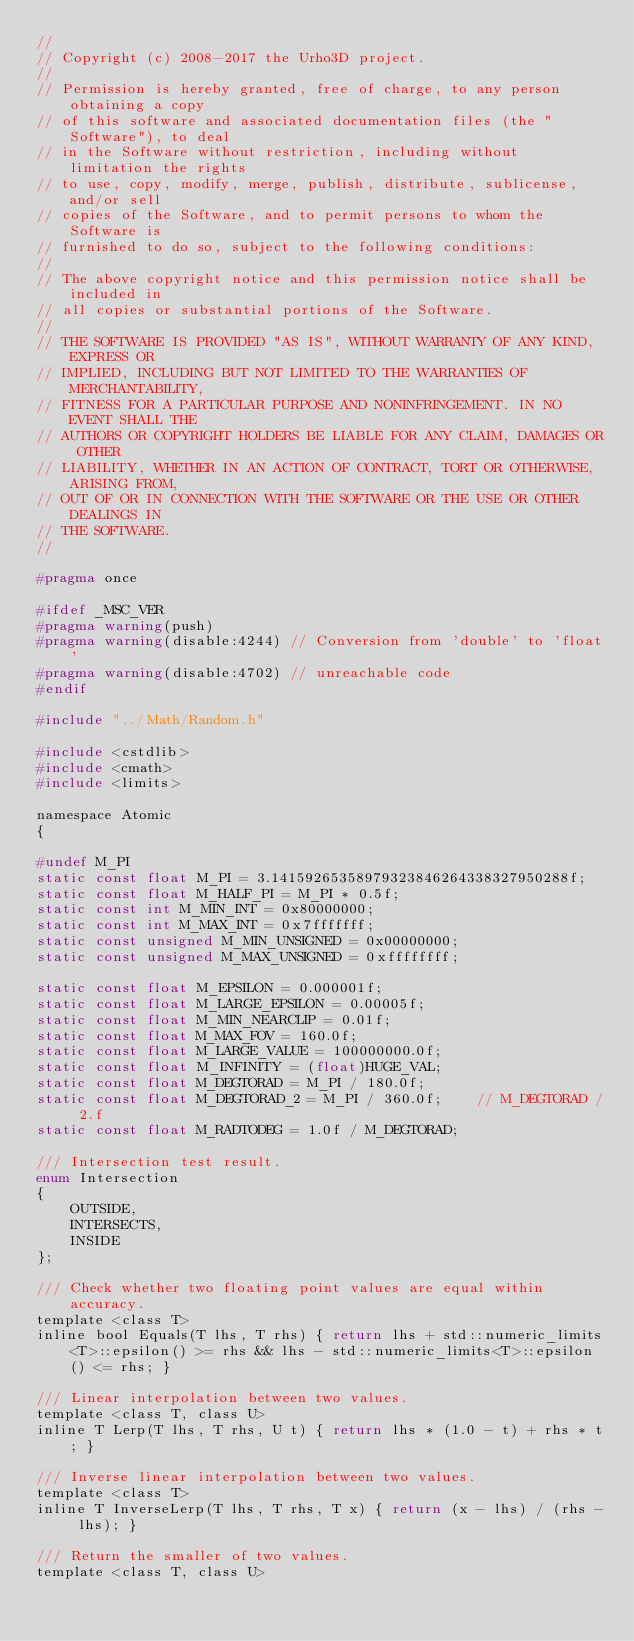Convert code to text. <code><loc_0><loc_0><loc_500><loc_500><_C_>//
// Copyright (c) 2008-2017 the Urho3D project.
//
// Permission is hereby granted, free of charge, to any person obtaining a copy
// of this software and associated documentation files (the "Software"), to deal
// in the Software without restriction, including without limitation the rights
// to use, copy, modify, merge, publish, distribute, sublicense, and/or sell
// copies of the Software, and to permit persons to whom the Software is
// furnished to do so, subject to the following conditions:
//
// The above copyright notice and this permission notice shall be included in
// all copies or substantial portions of the Software.
//
// THE SOFTWARE IS PROVIDED "AS IS", WITHOUT WARRANTY OF ANY KIND, EXPRESS OR
// IMPLIED, INCLUDING BUT NOT LIMITED TO THE WARRANTIES OF MERCHANTABILITY,
// FITNESS FOR A PARTICULAR PURPOSE AND NONINFRINGEMENT. IN NO EVENT SHALL THE
// AUTHORS OR COPYRIGHT HOLDERS BE LIABLE FOR ANY CLAIM, DAMAGES OR OTHER
// LIABILITY, WHETHER IN AN ACTION OF CONTRACT, TORT OR OTHERWISE, ARISING FROM,
// OUT OF OR IN CONNECTION WITH THE SOFTWARE OR THE USE OR OTHER DEALINGS IN
// THE SOFTWARE.
//

#pragma once

#ifdef _MSC_VER
#pragma warning(push)
#pragma warning(disable:4244) // Conversion from 'double' to 'float'
#pragma warning(disable:4702) // unreachable code
#endif

#include "../Math/Random.h"

#include <cstdlib>
#include <cmath>
#include <limits>

namespace Atomic
{

#undef M_PI
static const float M_PI = 3.14159265358979323846264338327950288f;
static const float M_HALF_PI = M_PI * 0.5f;
static const int M_MIN_INT = 0x80000000;
static const int M_MAX_INT = 0x7fffffff;
static const unsigned M_MIN_UNSIGNED = 0x00000000;
static const unsigned M_MAX_UNSIGNED = 0xffffffff;

static const float M_EPSILON = 0.000001f;
static const float M_LARGE_EPSILON = 0.00005f;
static const float M_MIN_NEARCLIP = 0.01f;
static const float M_MAX_FOV = 160.0f;
static const float M_LARGE_VALUE = 100000000.0f;
static const float M_INFINITY = (float)HUGE_VAL;
static const float M_DEGTORAD = M_PI / 180.0f;
static const float M_DEGTORAD_2 = M_PI / 360.0f;    // M_DEGTORAD / 2.f
static const float M_RADTODEG = 1.0f / M_DEGTORAD;

/// Intersection test result.
enum Intersection
{
    OUTSIDE,
    INTERSECTS,
    INSIDE
};

/// Check whether two floating point values are equal within accuracy.
template <class T>
inline bool Equals(T lhs, T rhs) { return lhs + std::numeric_limits<T>::epsilon() >= rhs && lhs - std::numeric_limits<T>::epsilon() <= rhs; }

/// Linear interpolation between two values.
template <class T, class U>
inline T Lerp(T lhs, T rhs, U t) { return lhs * (1.0 - t) + rhs * t; }

/// Inverse linear interpolation between two values.
template <class T>
inline T InverseLerp(T lhs, T rhs, T x) { return (x - lhs) / (rhs - lhs); }

/// Return the smaller of two values.
template <class T, class U></code> 